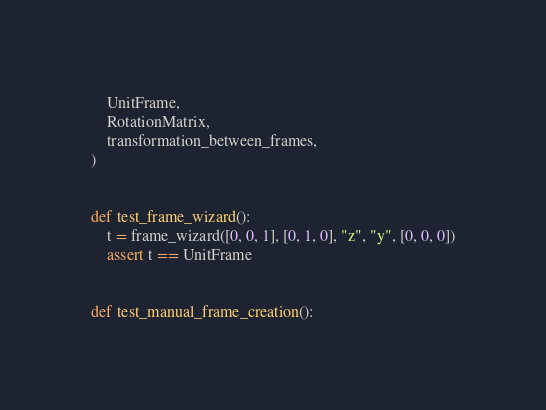<code> <loc_0><loc_0><loc_500><loc_500><_Python_>    UnitFrame,
    RotationMatrix,
    transformation_between_frames,
)


def test_frame_wizard():
    t = frame_wizard([0, 0, 1], [0, 1, 0], "z", "y", [0, 0, 0])
    assert t == UnitFrame


def test_manual_frame_creation():</code> 